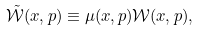Convert formula to latex. <formula><loc_0><loc_0><loc_500><loc_500>\tilde { \mathcal { W } } ( x , p ) \equiv \mu ( x , p ) { \mathcal { W } } ( x , p ) ,</formula> 